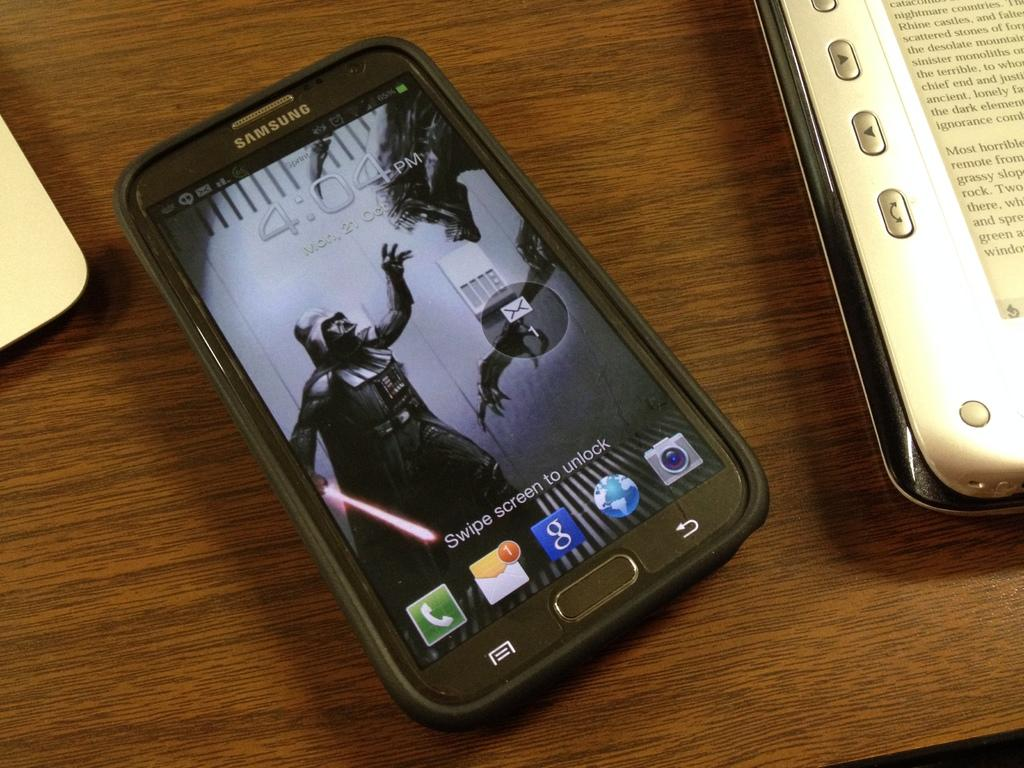<image>
Present a compact description of the photo's key features. A Samsung phone with a Star Wars wallpaper shows the time at 4:04 PM. 